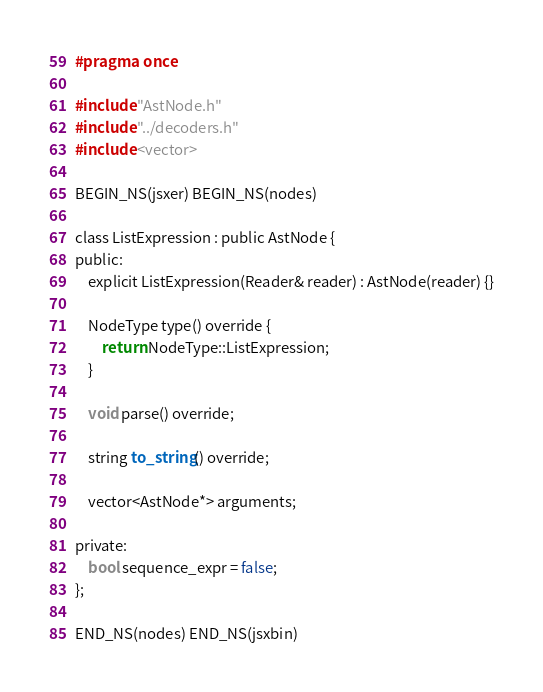<code> <loc_0><loc_0><loc_500><loc_500><_C_>#pragma once

#include "AstNode.h"
#include "../decoders.h"
#include <vector>

BEGIN_NS(jsxer) BEGIN_NS(nodes)

class ListExpression : public AstNode {
public:
    explicit ListExpression(Reader& reader) : AstNode(reader) {}

    NodeType type() override {
        return NodeType::ListExpression;
    }

    void parse() override;

    string to_string() override;

    vector<AstNode*> arguments;

private:
    bool sequence_expr = false;
};

END_NS(nodes) END_NS(jsxbin)
</code> 